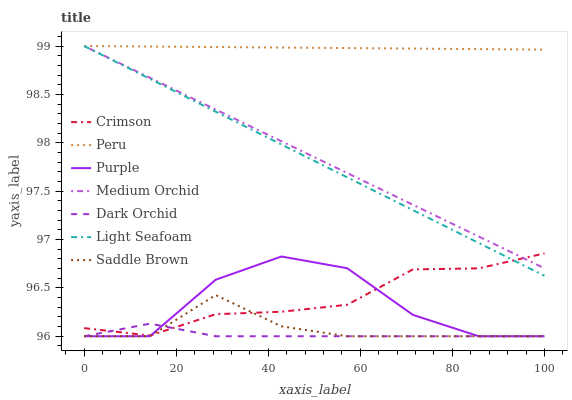Does Dark Orchid have the minimum area under the curve?
Answer yes or no. Yes. Does Peru have the maximum area under the curve?
Answer yes or no. Yes. Does Medium Orchid have the minimum area under the curve?
Answer yes or no. No. Does Medium Orchid have the maximum area under the curve?
Answer yes or no. No. Is Medium Orchid the smoothest?
Answer yes or no. Yes. Is Purple the roughest?
Answer yes or no. Yes. Is Dark Orchid the smoothest?
Answer yes or no. No. Is Dark Orchid the roughest?
Answer yes or no. No. Does Medium Orchid have the lowest value?
Answer yes or no. No. Does Dark Orchid have the highest value?
Answer yes or no. No. Is Dark Orchid less than Light Seafoam?
Answer yes or no. Yes. Is Medium Orchid greater than Saddle Brown?
Answer yes or no. Yes. Does Dark Orchid intersect Light Seafoam?
Answer yes or no. No. 